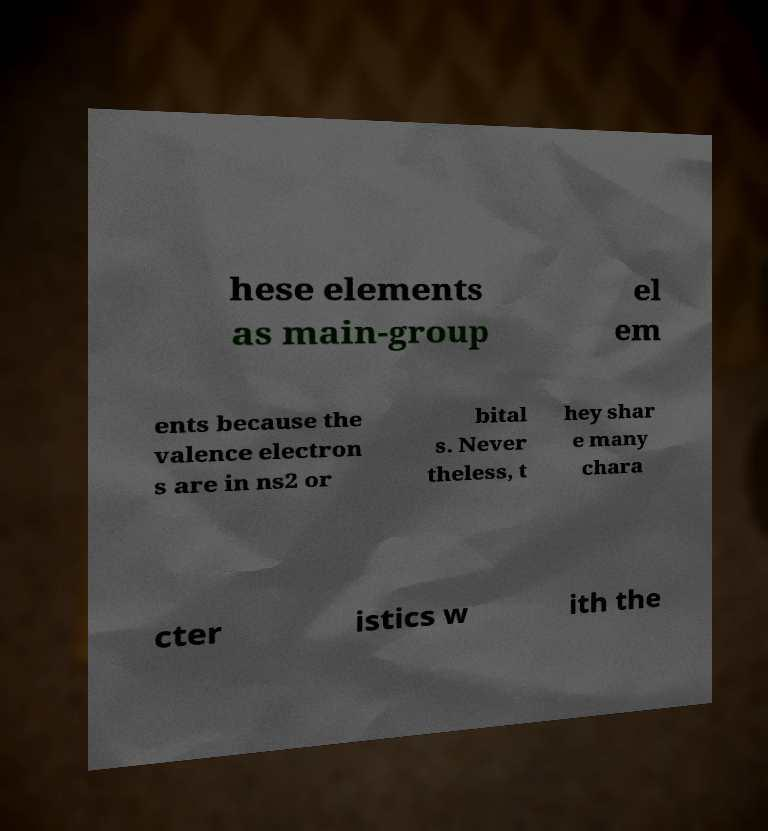What messages or text are displayed in this image? I need them in a readable, typed format. hese elements as main-group el em ents because the valence electron s are in ns2 or bital s. Never theless, t hey shar e many chara cter istics w ith the 